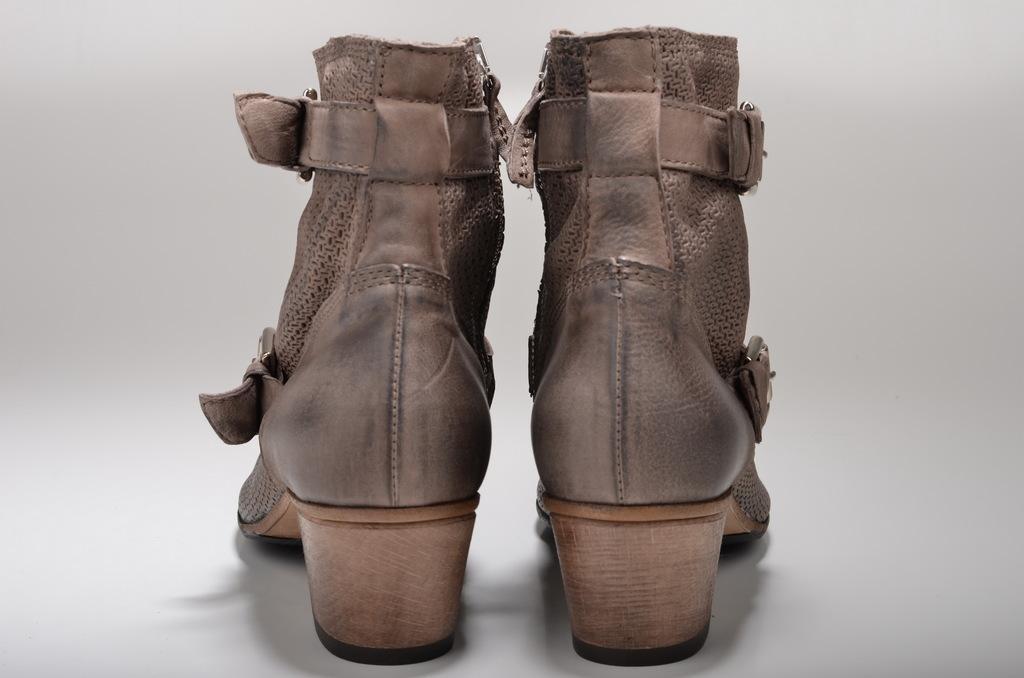Could you give a brief overview of what you see in this image? In the picture we can see footwear and there is a white background. 